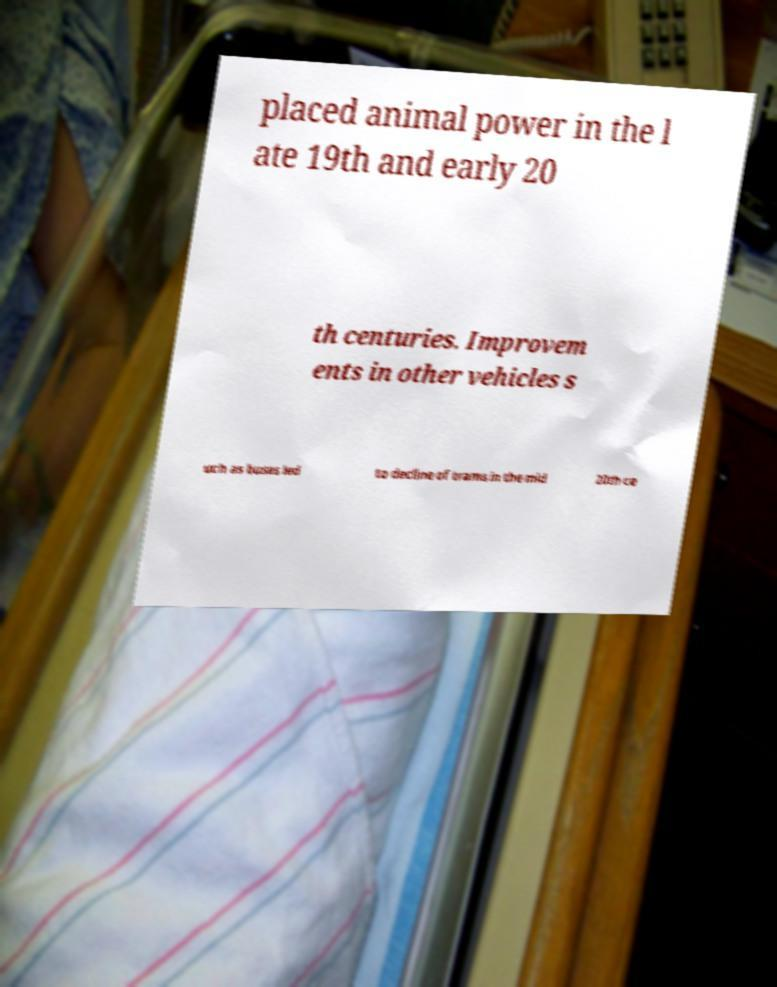Please read and relay the text visible in this image. What does it say? placed animal power in the l ate 19th and early 20 th centuries. Improvem ents in other vehicles s uch as buses led to decline of trams in the mid 20th ce 